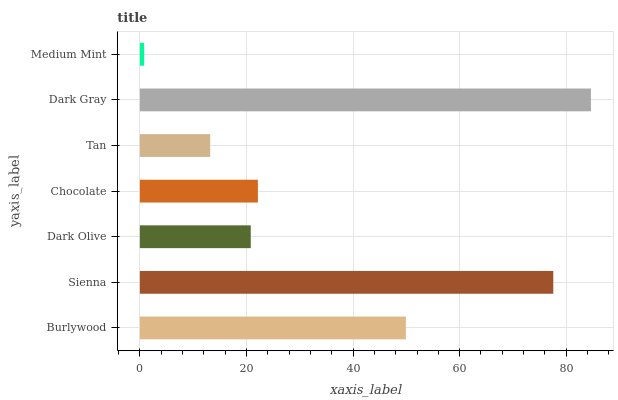Is Medium Mint the minimum?
Answer yes or no. Yes. Is Dark Gray the maximum?
Answer yes or no. Yes. Is Sienna the minimum?
Answer yes or no. No. Is Sienna the maximum?
Answer yes or no. No. Is Sienna greater than Burlywood?
Answer yes or no. Yes. Is Burlywood less than Sienna?
Answer yes or no. Yes. Is Burlywood greater than Sienna?
Answer yes or no. No. Is Sienna less than Burlywood?
Answer yes or no. No. Is Chocolate the high median?
Answer yes or no. Yes. Is Chocolate the low median?
Answer yes or no. Yes. Is Burlywood the high median?
Answer yes or no. No. Is Sienna the low median?
Answer yes or no. No. 